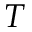Convert formula to latex. <formula><loc_0><loc_0><loc_500><loc_500>T</formula> 